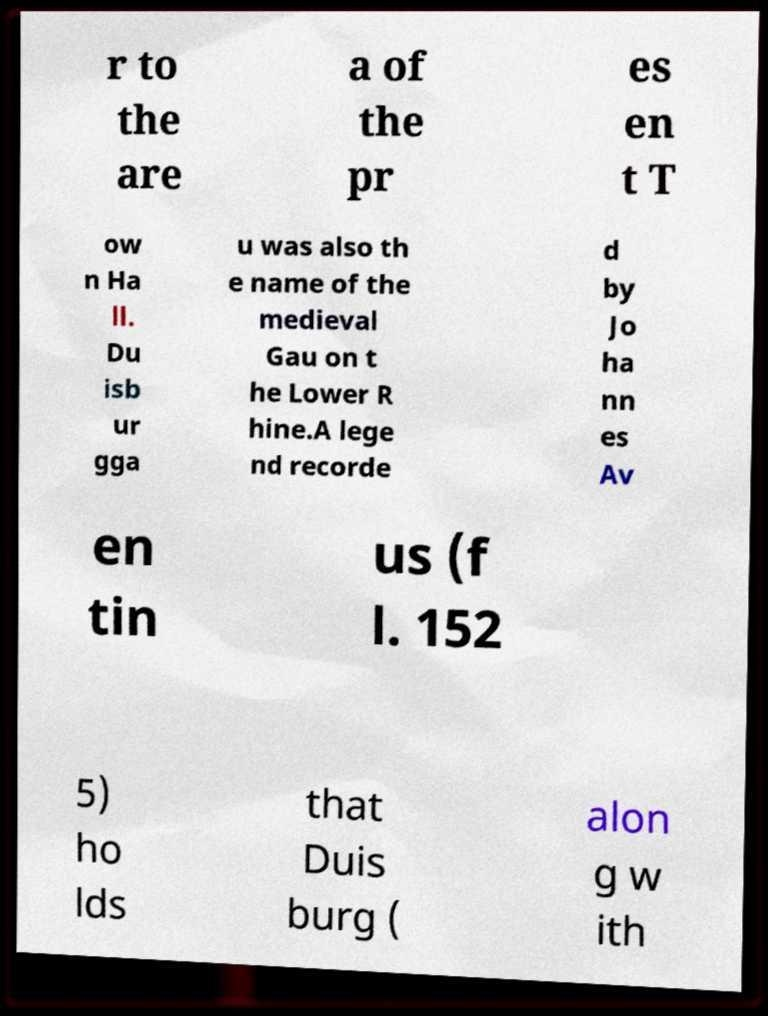Could you assist in decoding the text presented in this image and type it out clearly? r to the are a of the pr es en t T ow n Ha ll. Du isb ur gga u was also th e name of the medieval Gau on t he Lower R hine.A lege nd recorde d by Jo ha nn es Av en tin us (f l. 152 5) ho lds that Duis burg ( alon g w ith 